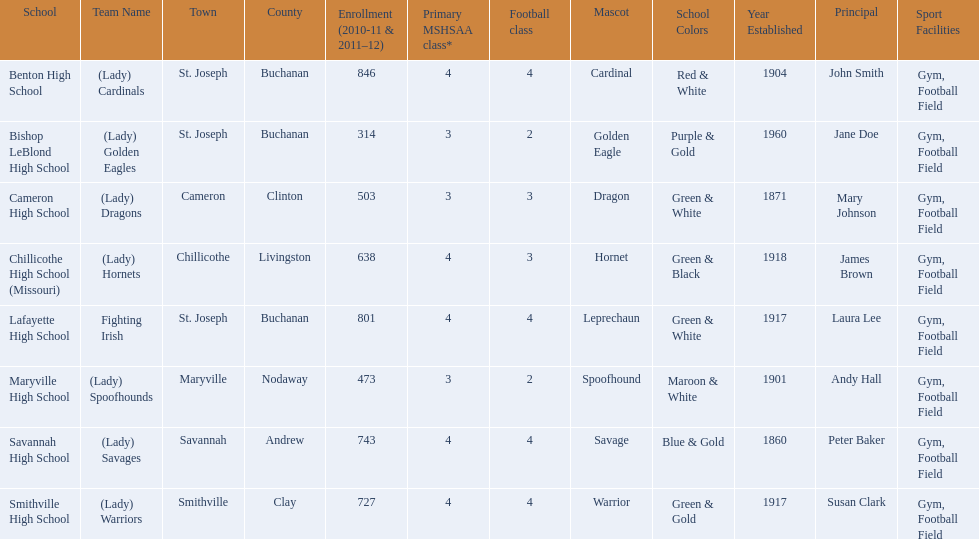Does lafayette high school or benton high school have green and grey as their colors? Lafayette High School. 